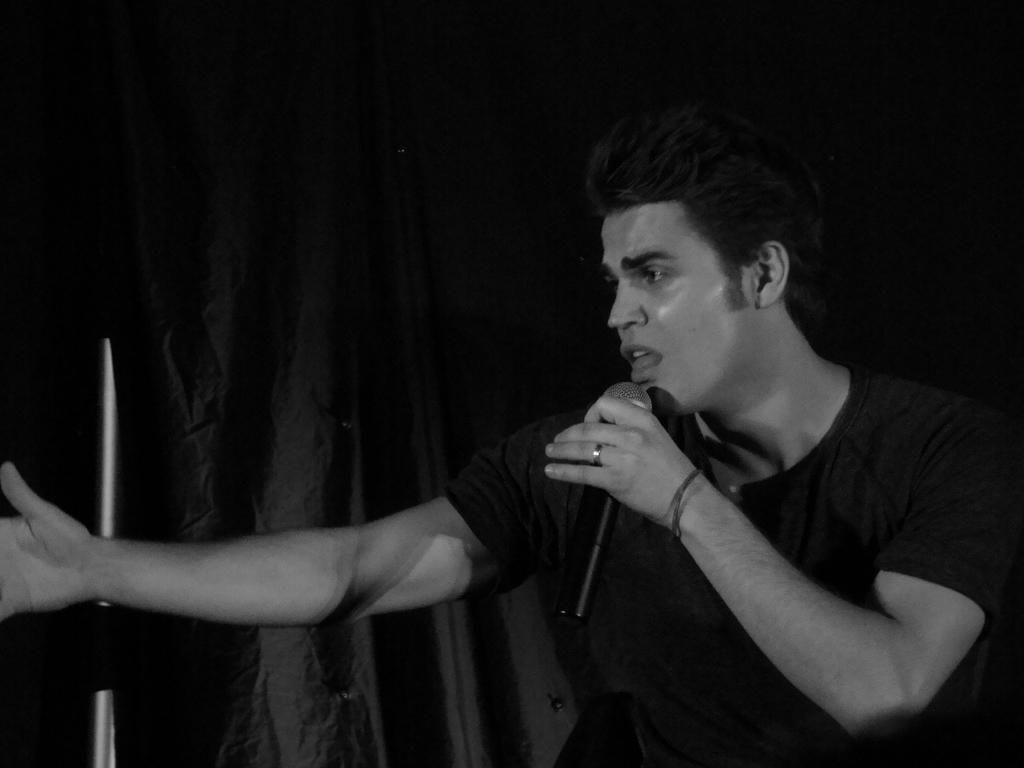Who is present in the image? There is a man in the image. What is the man holding in his hand? The man is holding a mic in his hand. What can be seen in the background of the image? There is a curtain in the background of the image. Is there a woman sitting at a table in the image? No, there is no woman or table present in the image. 